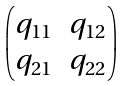Convert formula to latex. <formula><loc_0><loc_0><loc_500><loc_500>\begin{pmatrix} q _ { 1 1 } & q _ { 1 2 } \\ q _ { 2 1 } & q _ { 2 2 } \end{pmatrix}</formula> 